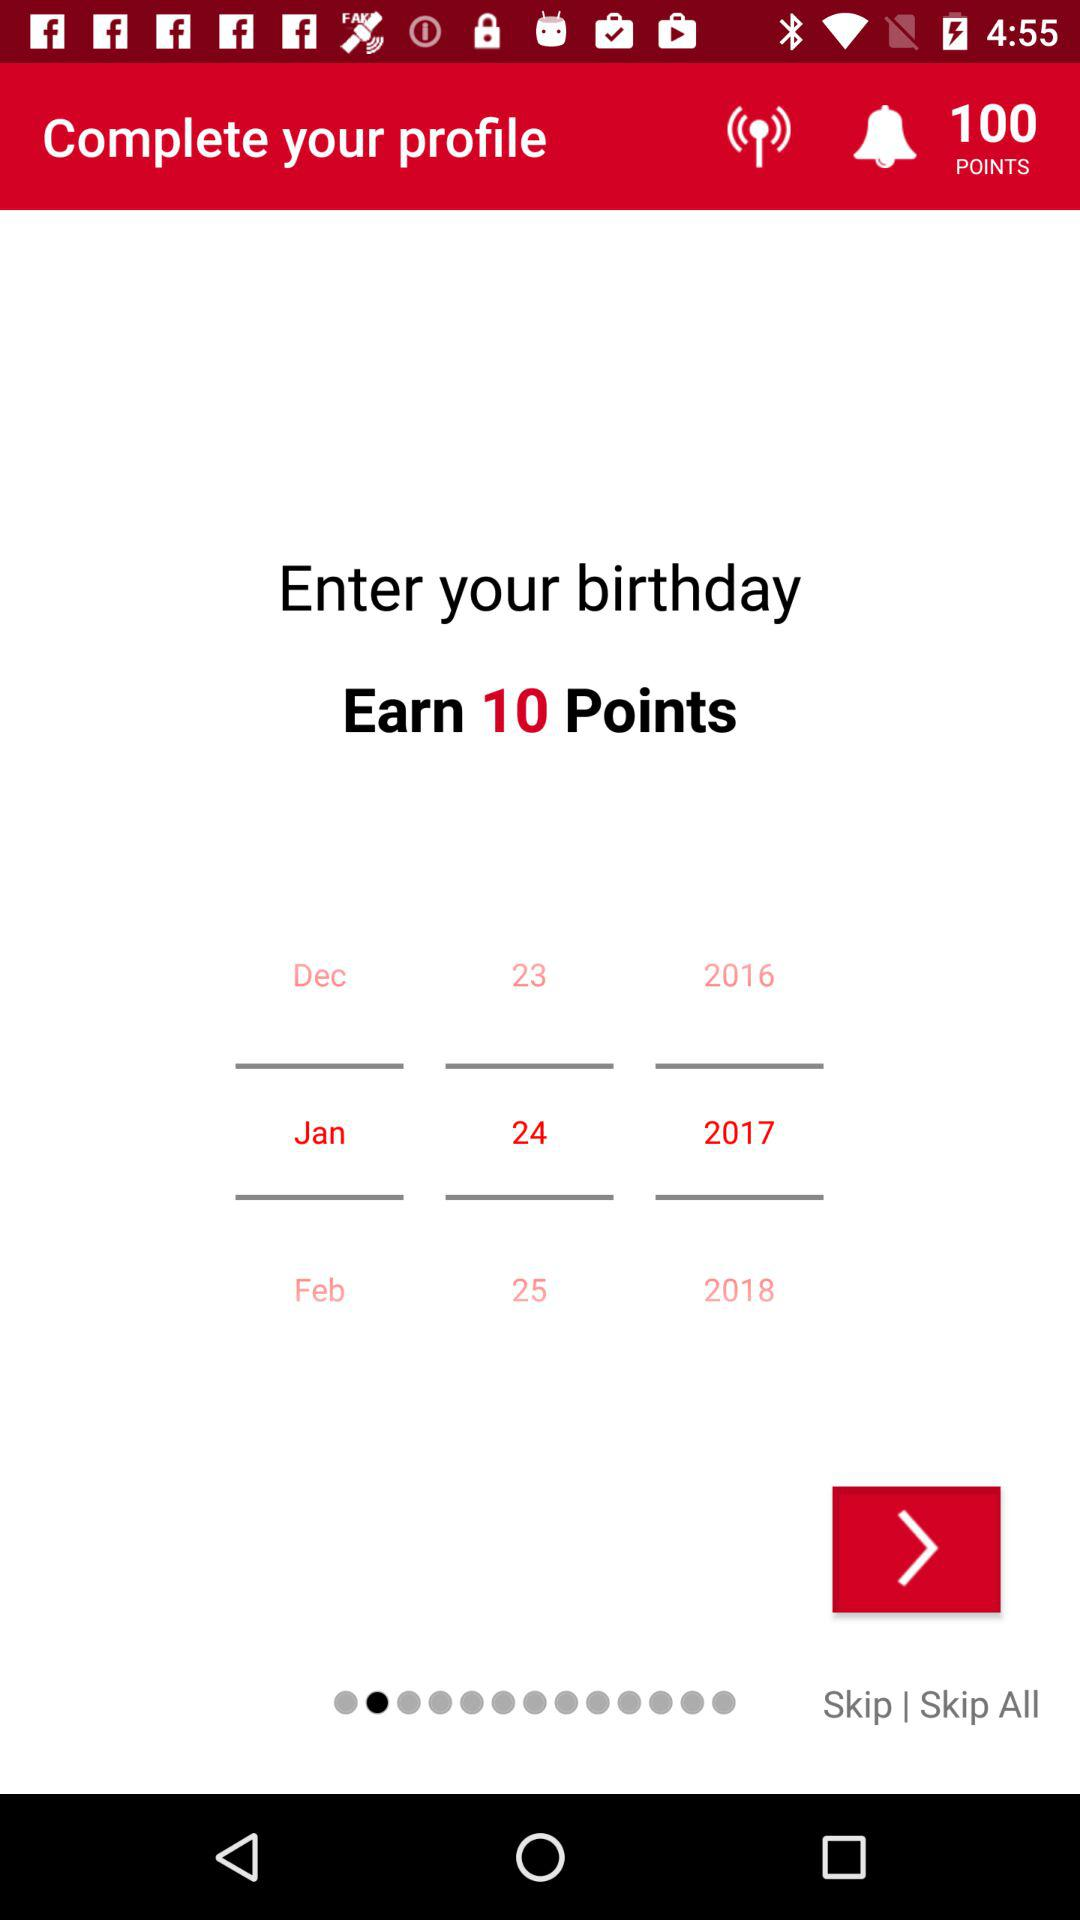What is the total number of earned points? The total number of earned points is 100. 